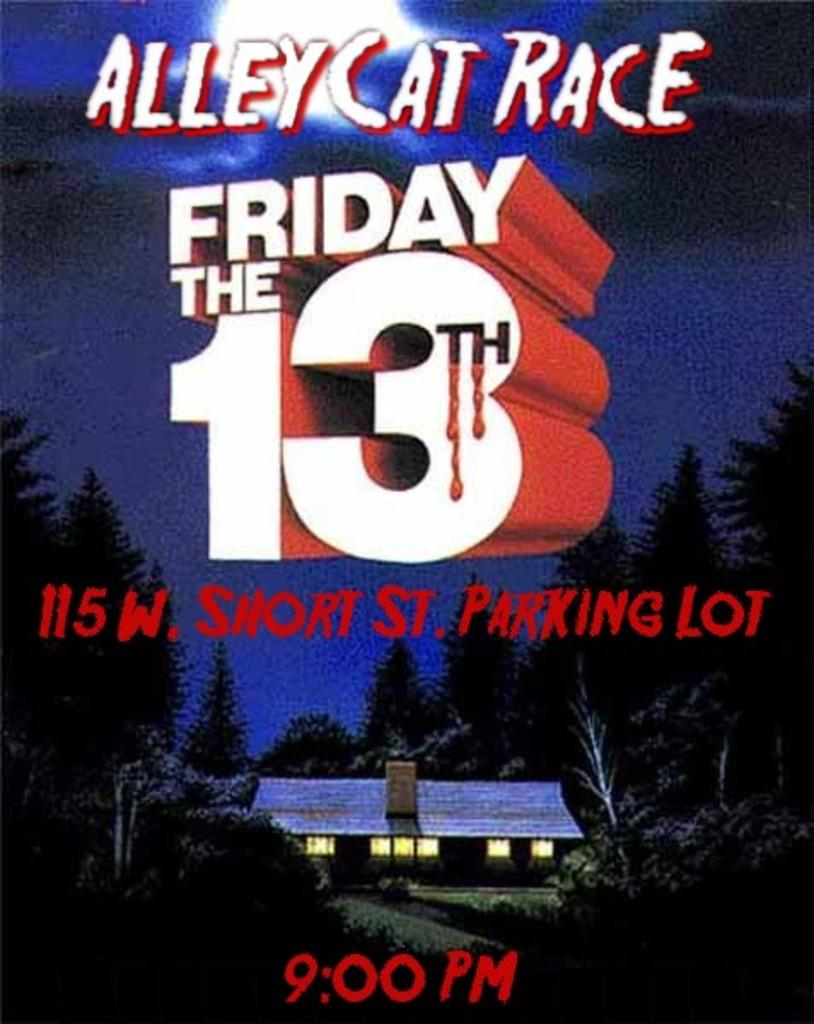<image>
Offer a succinct explanation of the picture presented. A flyer for an Alley Cat Race on Friday the 13th at 9 PM at 115 W Short St Parking Lot. 